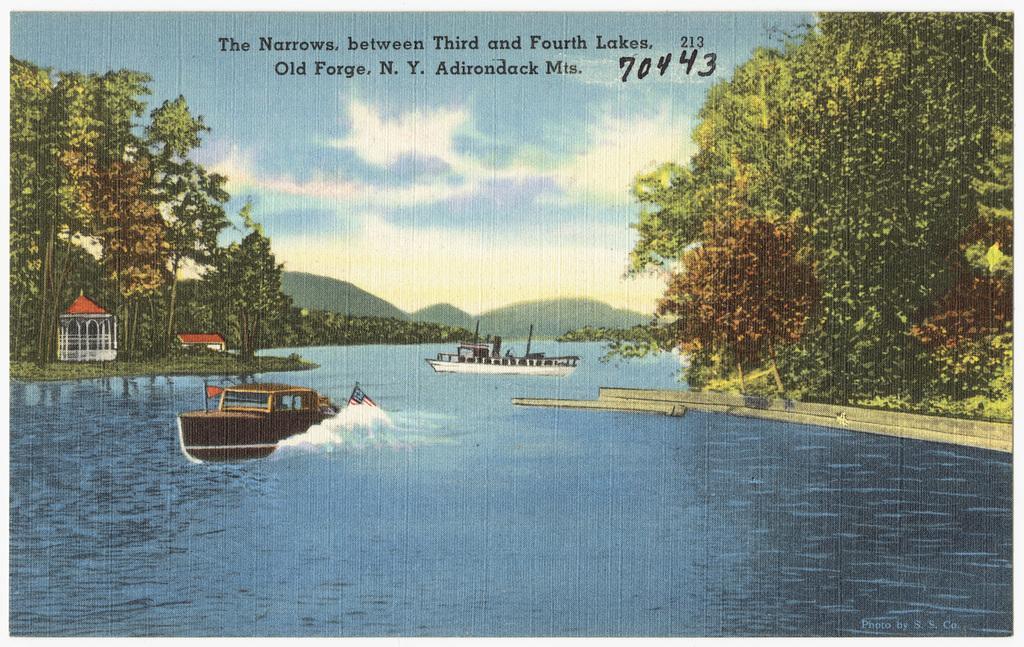Please provide a concise description of this image. This looks like a poster. I can see two boats moving on the water. These are the trees. I can see a small house. In the background, these are the hills. These are the letters in the image. 